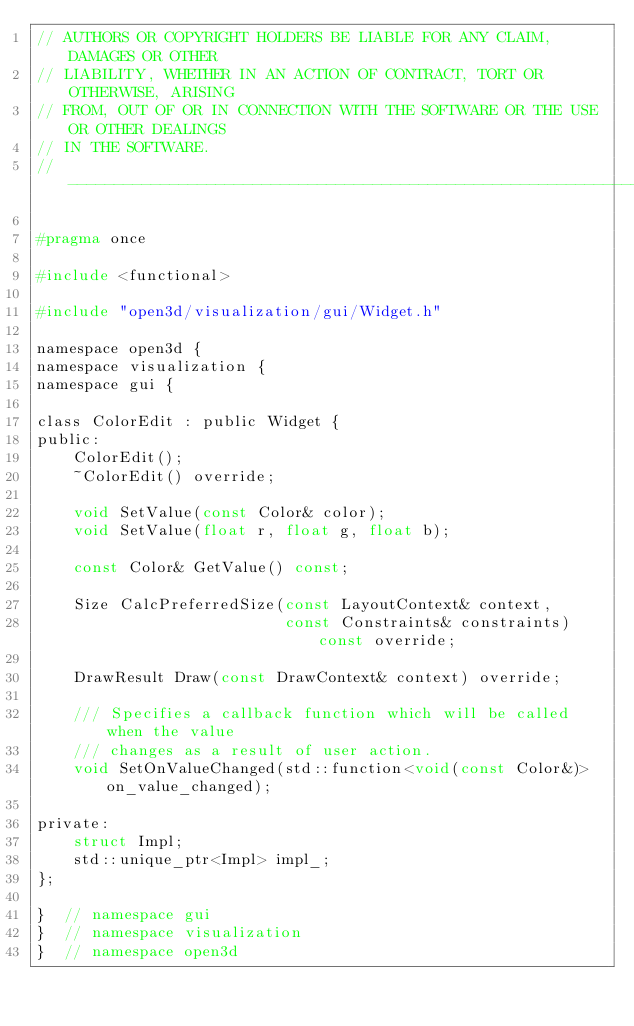<code> <loc_0><loc_0><loc_500><loc_500><_C_>// AUTHORS OR COPYRIGHT HOLDERS BE LIABLE FOR ANY CLAIM, DAMAGES OR OTHER
// LIABILITY, WHETHER IN AN ACTION OF CONTRACT, TORT OR OTHERWISE, ARISING
// FROM, OUT OF OR IN CONNECTION WITH THE SOFTWARE OR THE USE OR OTHER DEALINGS
// IN THE SOFTWARE.
// ----------------------------------------------------------------------------

#pragma once

#include <functional>

#include "open3d/visualization/gui/Widget.h"

namespace open3d {
namespace visualization {
namespace gui {

class ColorEdit : public Widget {
public:
    ColorEdit();
    ~ColorEdit() override;

    void SetValue(const Color& color);
    void SetValue(float r, float g, float b);

    const Color& GetValue() const;

    Size CalcPreferredSize(const LayoutContext& context,
                           const Constraints& constraints) const override;

    DrawResult Draw(const DrawContext& context) override;

    /// Specifies a callback function which will be called when the value
    /// changes as a result of user action.
    void SetOnValueChanged(std::function<void(const Color&)> on_value_changed);

private:
    struct Impl;
    std::unique_ptr<Impl> impl_;
};

}  // namespace gui
}  // namespace visualization
}  // namespace open3d
</code> 